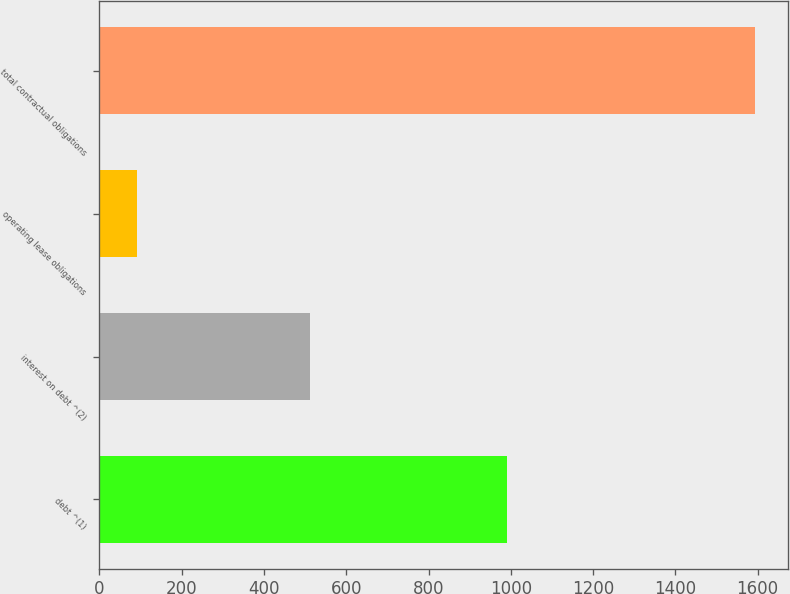Convert chart. <chart><loc_0><loc_0><loc_500><loc_500><bar_chart><fcel>debt ^(1)<fcel>interest on debt ^(2)<fcel>operating lease obligations<fcel>total contractual obligations<nl><fcel>991.8<fcel>511.3<fcel>90.7<fcel>1593.8<nl></chart> 